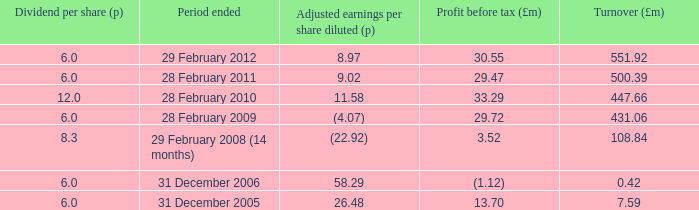What was the profit before tax when the turnover was 431.06? 29.72. 